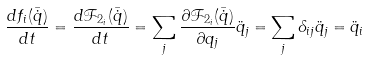<formula> <loc_0><loc_0><loc_500><loc_500>\frac { d f _ { i } ( \bar { \dot { q } } ) } { d t } = \frac { d \mathcal { F } _ { 2 _ { i } } ( \bar { \dot { q } } ) } { d t } = \sum _ { j } \frac { \partial \mathcal { F } _ { 2 _ { i } } ( \bar { \dot { q } } ) } { \partial q _ { j } } \ddot { q } _ { j } = \sum _ { j } \delta _ { i j } \ddot { q } _ { j } = \ddot { q } _ { i }</formula> 